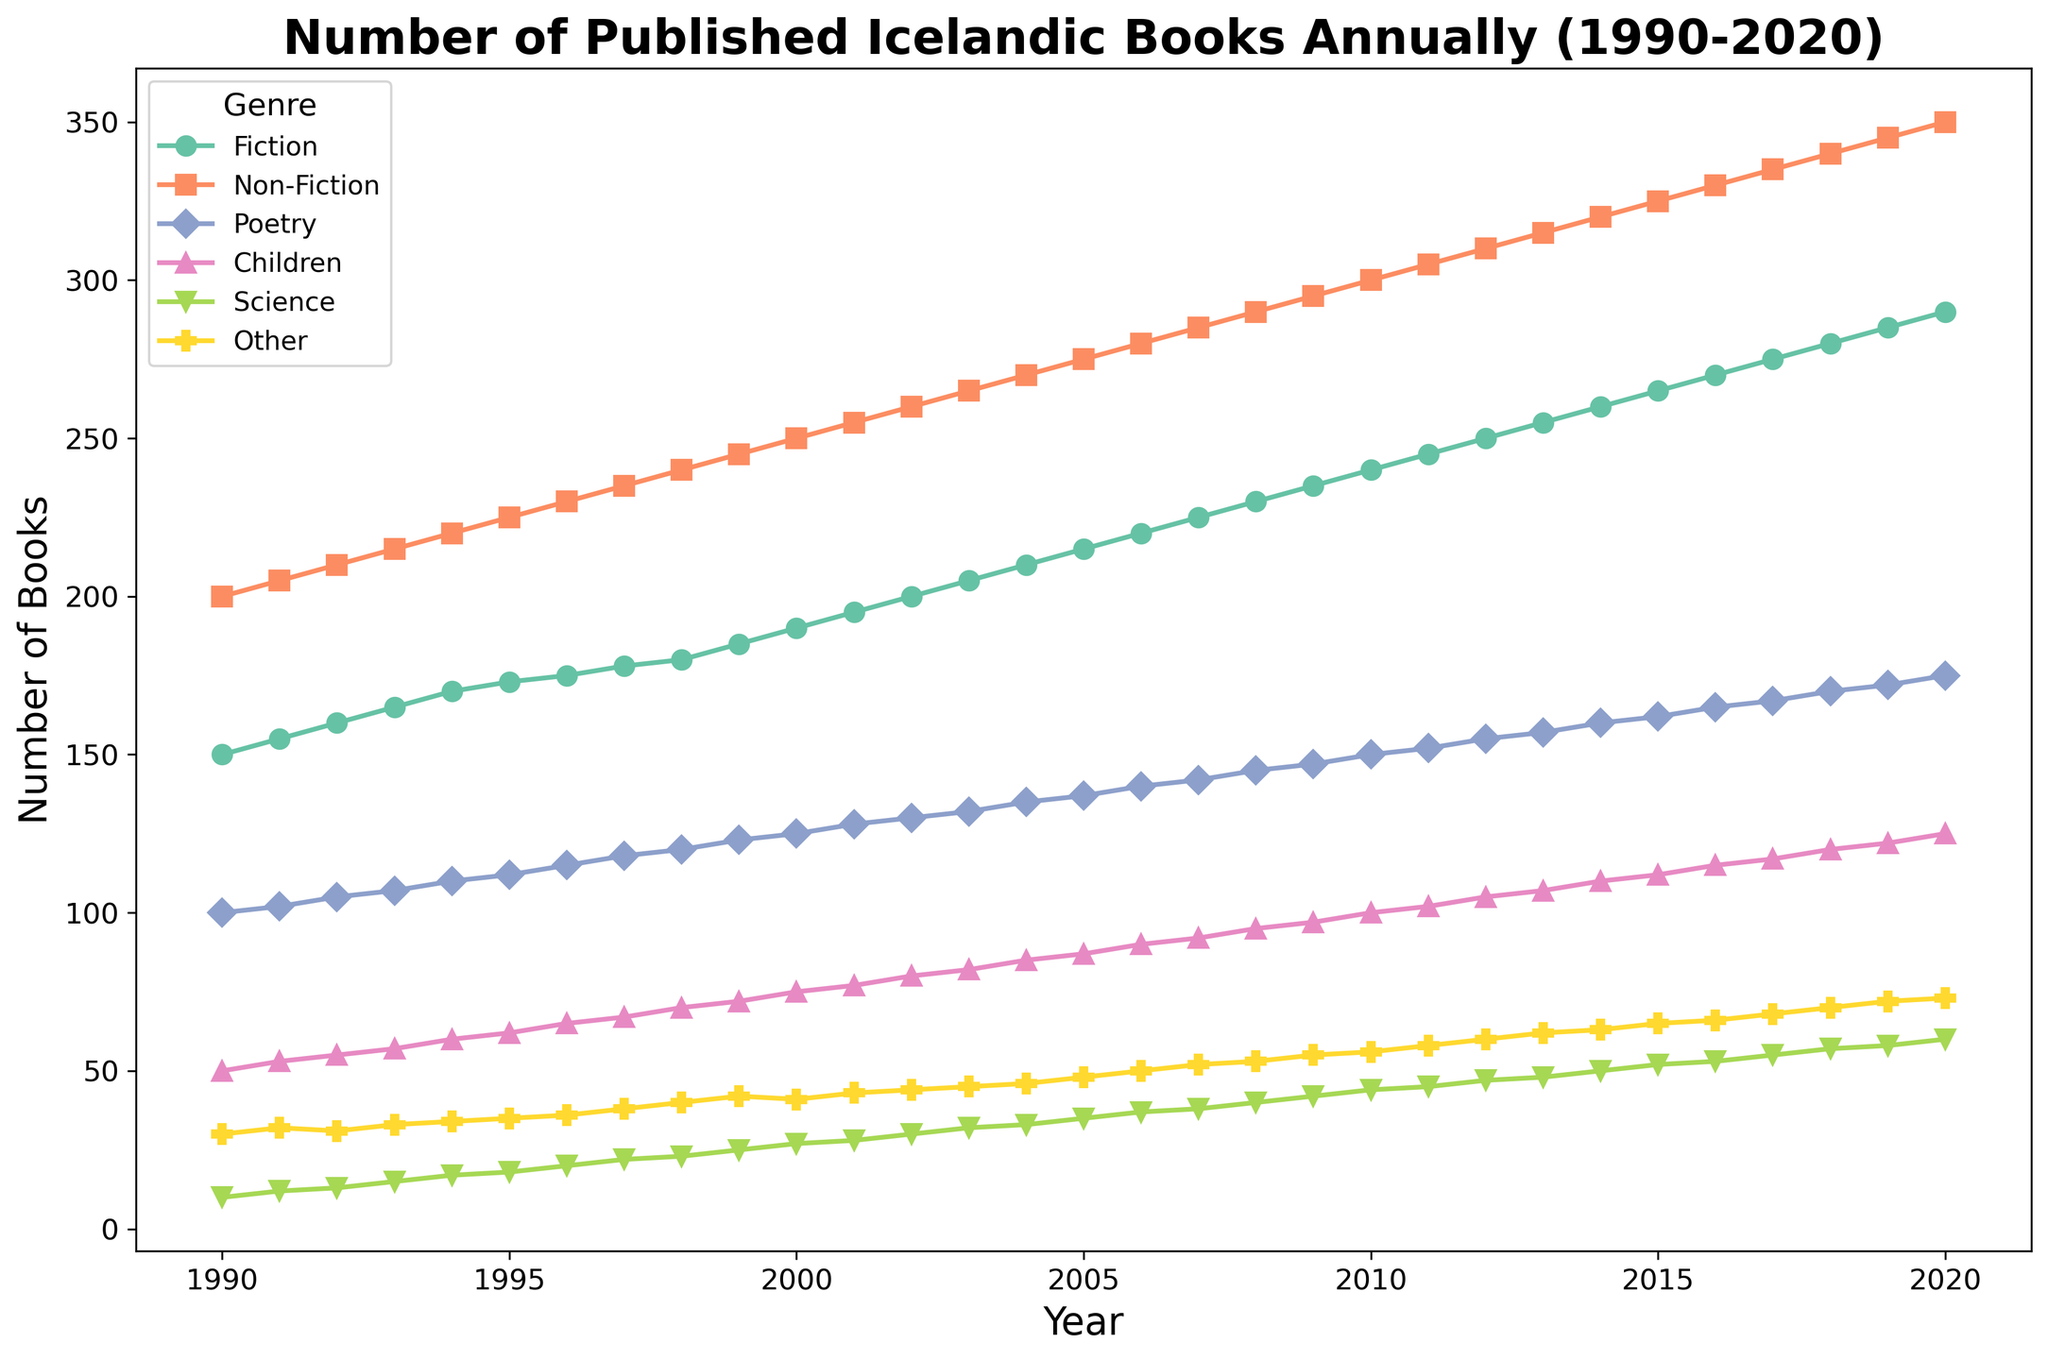How many Fiction books were published in 2000? Look at the plot point for Fiction in 2000. The marker shows it at 190.
Answer: 190 Which genre had the highest number of published books in 2010? Compare the values for all genres in 2010. The Non-Fiction genre has the highest value at 300.
Answer: Non-Fiction What is the difference in the number of Children books published between 2000 and 2020? In 2000, 75 Children books were published. In 2020, 125 Children books were published. The difference is 125 - 75 = 50.
Answer: 50 Which genre shows the most consistent (linear) growth over the years? Observe the lines for each genre. Non-Fiction shows a consistent, almost linear increase.
Answer: Non-Fiction What is the average number of Science books published annually from 2000 to 2020? Sum the number of Science books published each year from 2000 to 2020 and divide by the number of years. Sum: (27 + 28 + 30 + ... + 60), which results in 798. Average: 798 / 21 = 38.
Answer: 38 Between which two consecutive years is the largest increase in Poetry book publications? Look at the steepest slopes for Poetry. The largest increase happens between 1999 (123) and 2000 (125). The difference is 125 - 123 = 2.
Answer: 1999-2000 How does the number of Fiction books published in 2000 compare to the number of Fiction books published in 2010? In 2000, 190 Fiction books were published. In 2010, 240 Fiction books were published. The increase is 240 - 190 = 50.
Answer: There is an increase of 50 What are the colors used to represent the Poetry and Science genres in the figure? Observe the legend in the chart. Poetry is represented by a color, and Science by another distinct color, according to the plot.
Answer: Poetry: purple, Science: grey (example, confirm exact colors by viewing) What is the total number of books published in all genres combined in 1995? Add up the number of books in all genres for 1995. Total = 173 + 225 + 112 + 62 + 18 + 35 = 625.
Answer: 625 